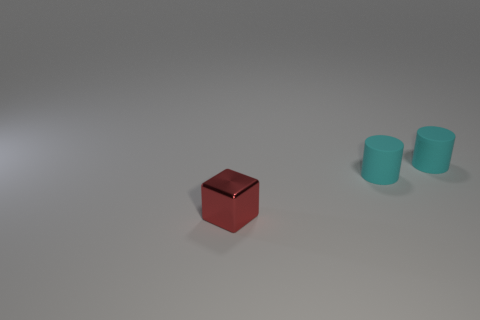Add 2 small shiny cubes. How many objects exist? 5 Subtract all cylinders. How many objects are left? 1 Add 3 tiny red things. How many tiny red things are left? 4 Add 2 tiny purple matte cubes. How many tiny purple matte cubes exist? 2 Subtract 1 red blocks. How many objects are left? 2 Subtract all green things. Subtract all matte cylinders. How many objects are left? 1 